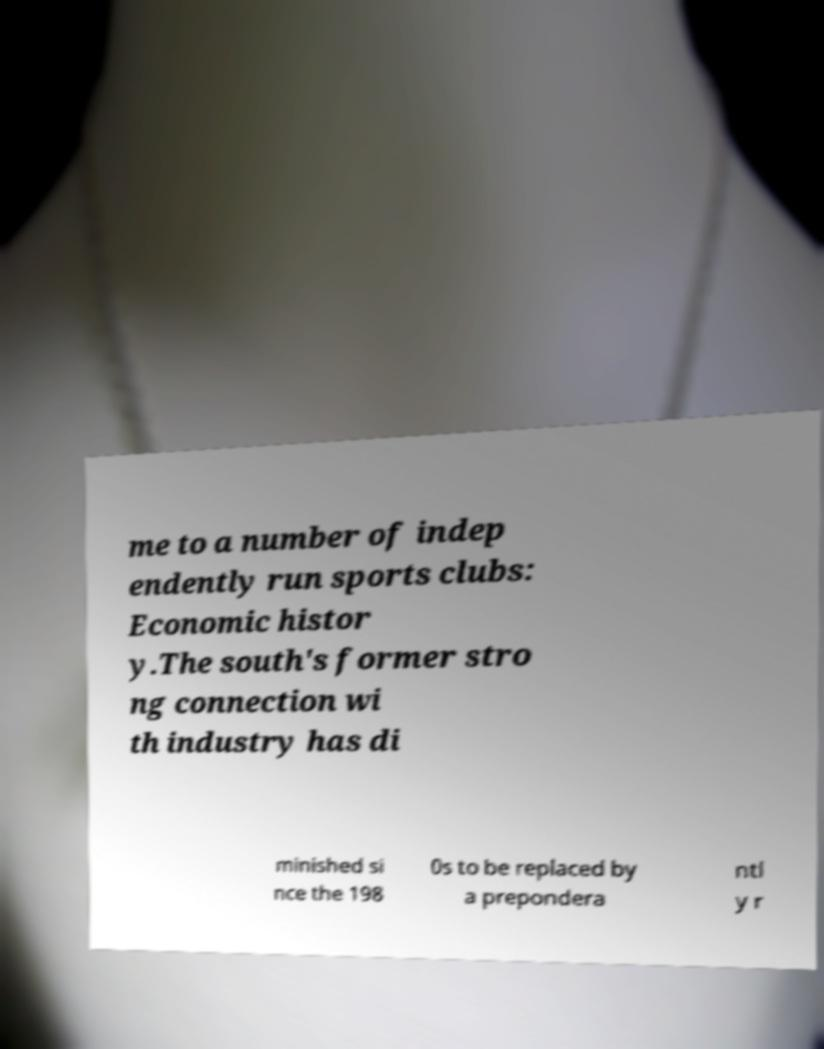I need the written content from this picture converted into text. Can you do that? me to a number of indep endently run sports clubs: Economic histor y.The south's former stro ng connection wi th industry has di minished si nce the 198 0s to be replaced by a prepondera ntl y r 